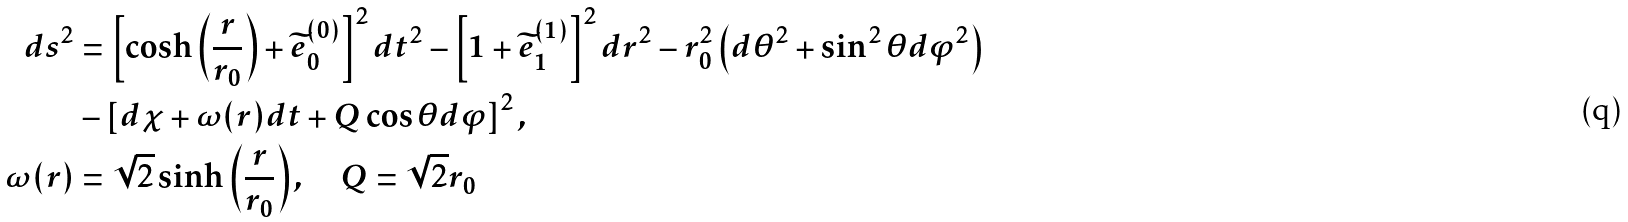Convert formula to latex. <formula><loc_0><loc_0><loc_500><loc_500>d s ^ { 2 } & = \left [ \cosh \left ( \frac { r } { r _ { 0 } } \right ) + \widetilde { e } ^ { ( 0 ) } _ { 0 } \right ] ^ { 2 } d t ^ { 2 } - \left [ 1 + \widetilde { e } ^ { ( 1 ) } _ { 1 } \right ] ^ { 2 } d r ^ { 2 } - r ^ { 2 } _ { 0 } \left ( d \theta ^ { 2 } + \sin ^ { 2 } \theta d \varphi ^ { 2 } \right ) \\ & - \left [ d \chi + \omega ( r ) d t + Q \cos \theta d \varphi \right ] ^ { 2 } , \\ \omega ( r ) & = \sqrt { 2 } \sinh \left ( \frac { r } { r _ { 0 } } \right ) , \quad Q = \sqrt { 2 } r _ { 0 }</formula> 